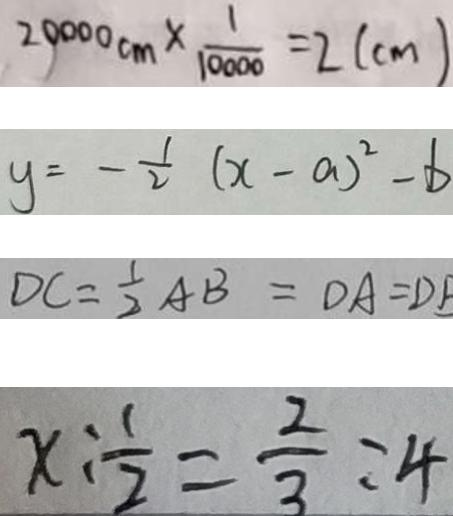<formula> <loc_0><loc_0><loc_500><loc_500>2 0 0 0 0 c m \times \frac { 1 } { 1 0 0 0 0 } = 2 ( c m ) 
 y = - \frac { 1 } { 2 } ( x - a ) ^ { 2 } - b 
 D C = \frac { 1 } { 2 } A B = D A = D B 
 x : \frac { 1 } { 2 } = \frac { 2 } { 3 } : 4</formula> 